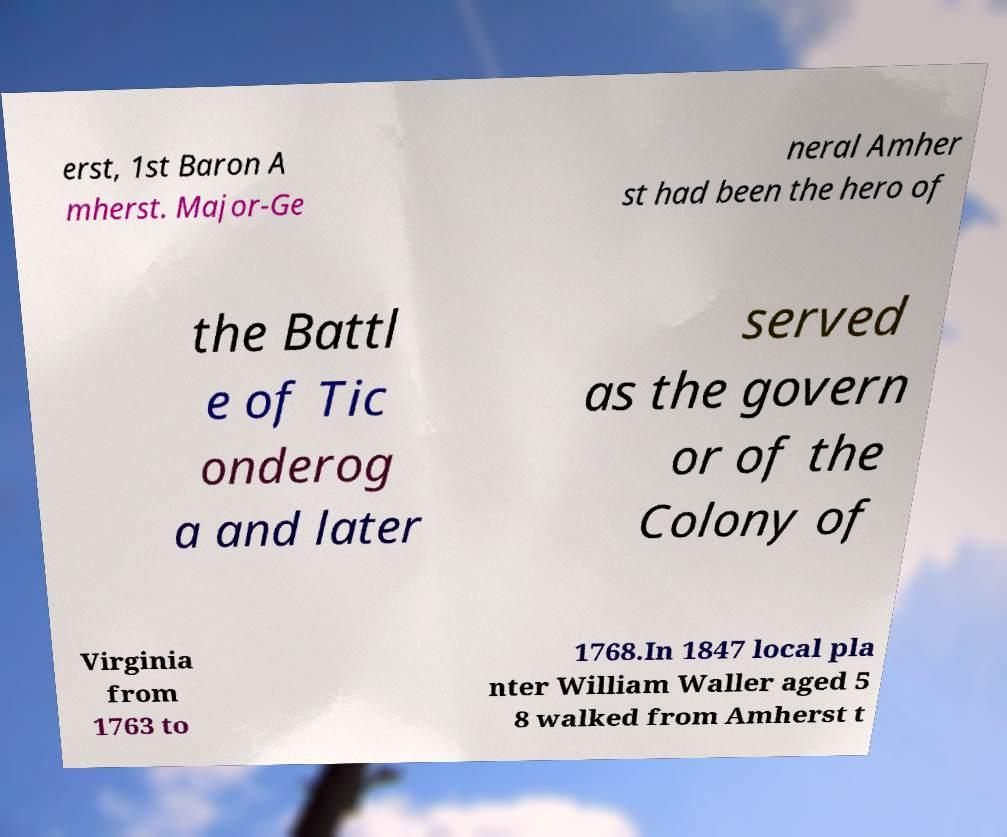Please identify and transcribe the text found in this image. erst, 1st Baron A mherst. Major-Ge neral Amher st had been the hero of the Battl e of Tic onderog a and later served as the govern or of the Colony of Virginia from 1763 to 1768.In 1847 local pla nter William Waller aged 5 8 walked from Amherst t 